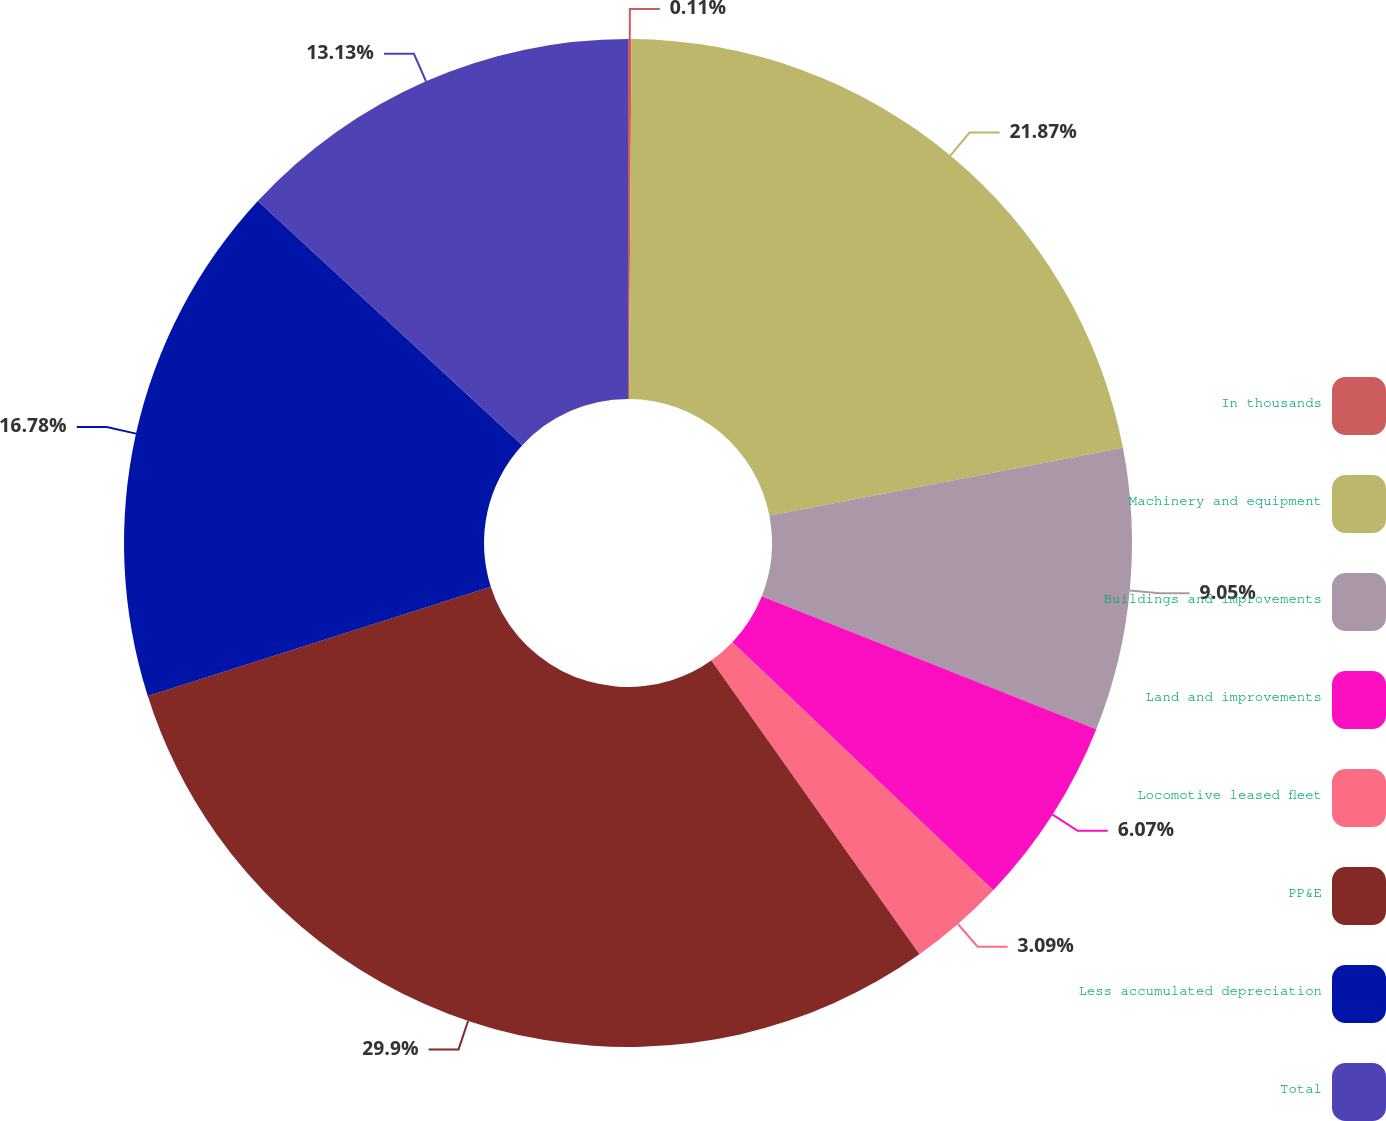Convert chart. <chart><loc_0><loc_0><loc_500><loc_500><pie_chart><fcel>In thousands<fcel>Machinery and equipment<fcel>Buildings and improvements<fcel>Land and improvements<fcel>Locomotive leased fleet<fcel>PP&E<fcel>Less accumulated depreciation<fcel>Total<nl><fcel>0.11%<fcel>21.87%<fcel>9.05%<fcel>6.07%<fcel>3.09%<fcel>29.91%<fcel>16.78%<fcel>13.13%<nl></chart> 